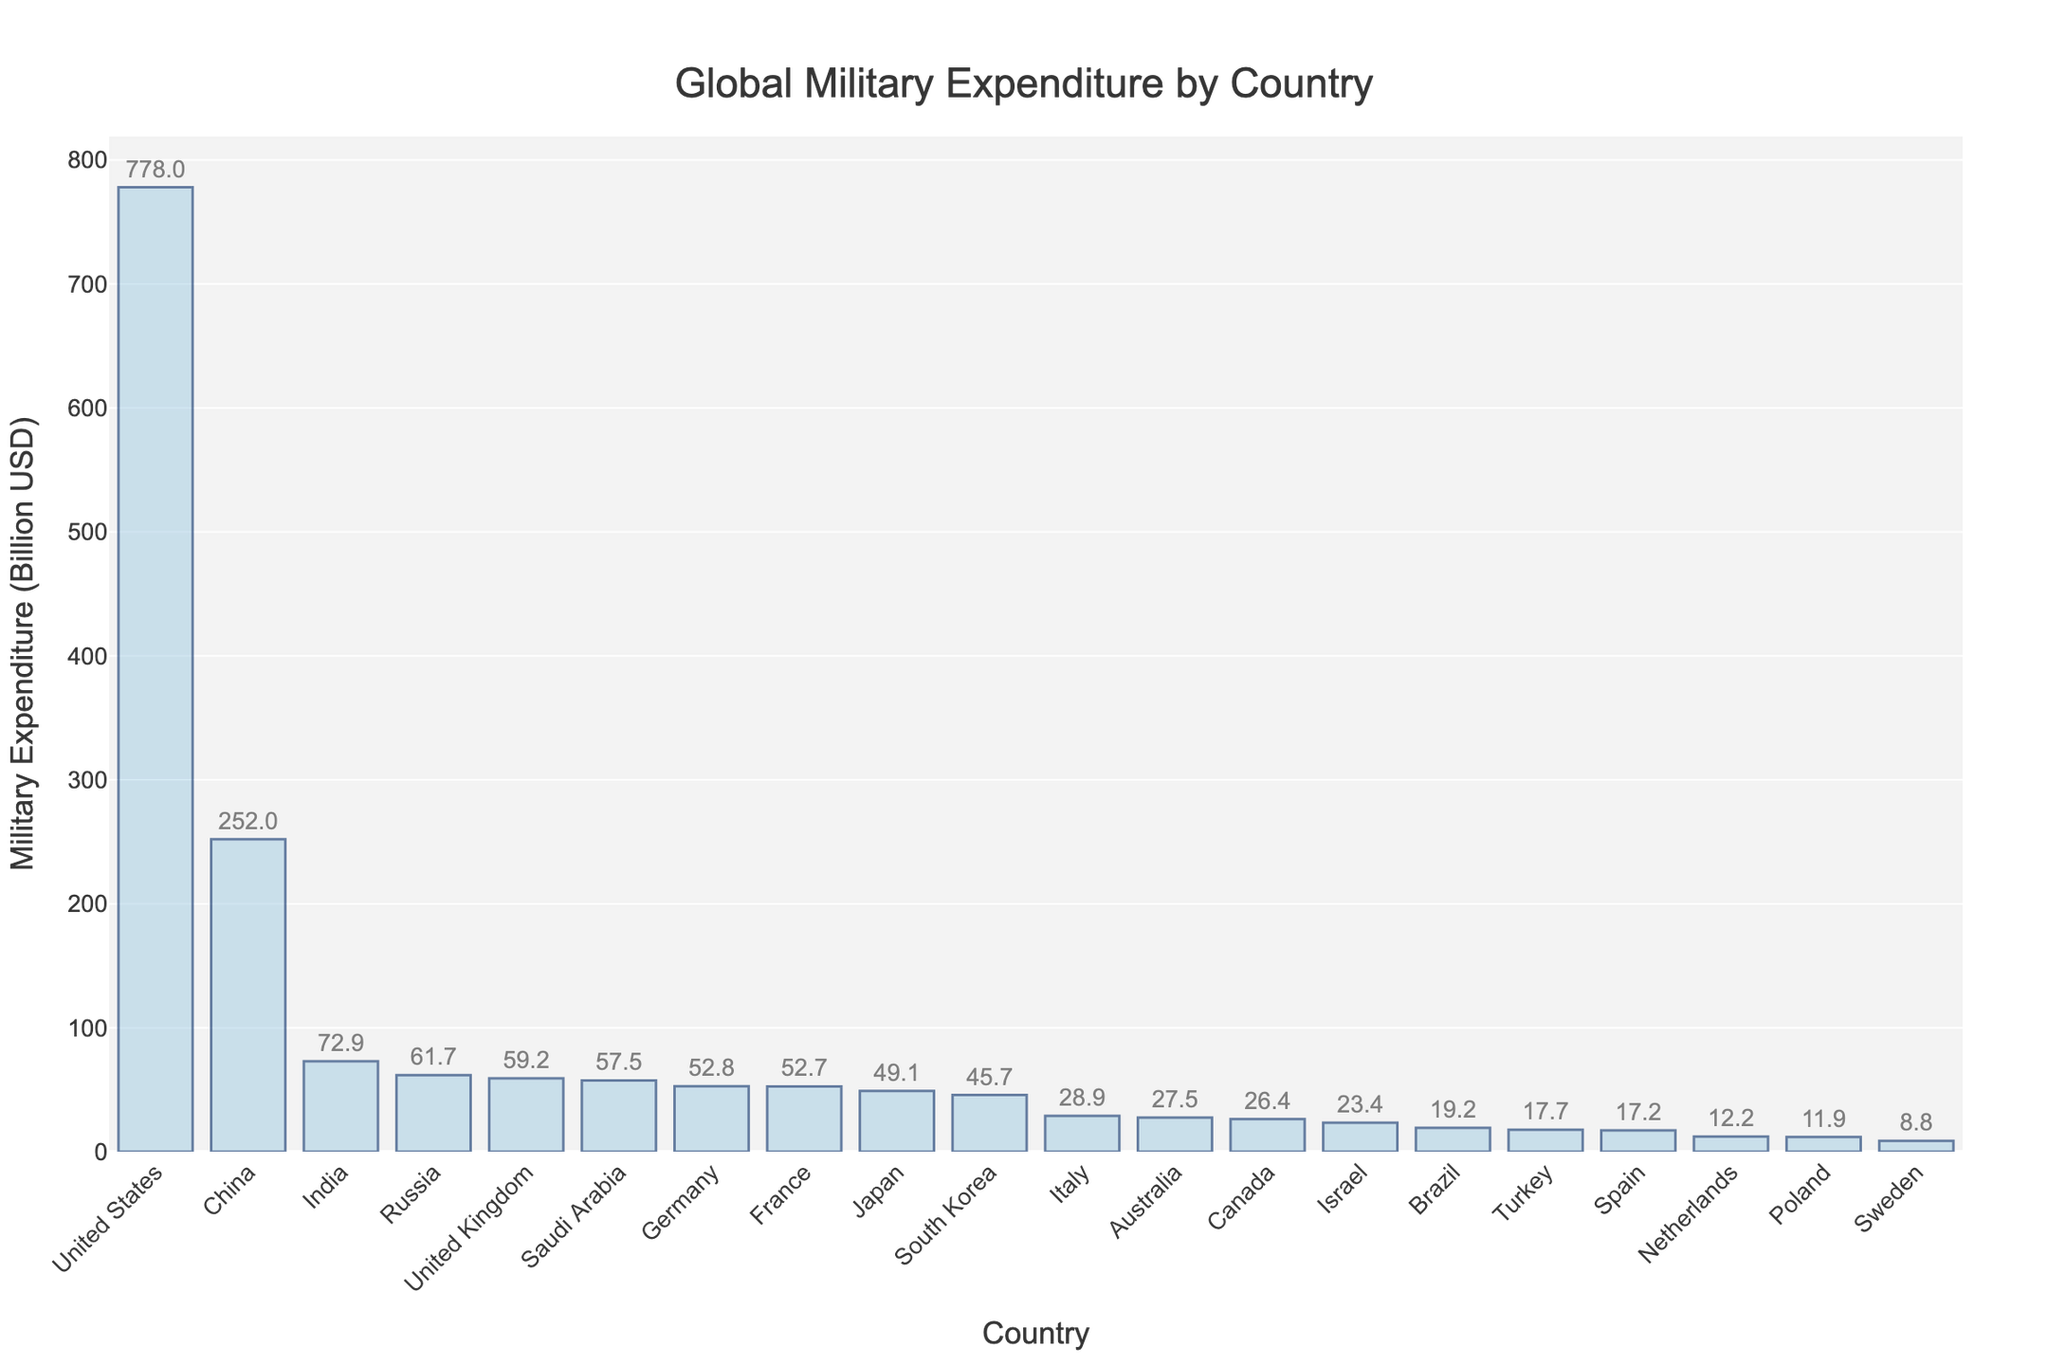Which country has the highest military expenditure? From the figure, the bar representing the United States is the tallest, indicating it has the highest military expenditure.
Answer: United States What is the total military expenditure of the top three countries? From the figure, the military expenditures of the top three countries are the United States (778 billion USD), China (252 billion USD), and India (72.9 billion USD). Adding these values together, 778 + 252 + 72.9 = 1102.9 billion USD.
Answer: 1102.9 billion USD How does the military expenditure of Russia compare to that of the United Kingdom? From the figure, the height of the bar for Russia (61.7 billion USD) is slightly higher than that for the United Kingdom (59.2 billion USD), meaning Russia spends more.
Answer: Russia spends more What is the difference in military expenditure between China and Japan? From the figure, the military expenditure of China is 252 billion USD and Japan is 49.1 billion USD. The difference is 252 - 49.1 = 202.9 billion USD.
Answer: 202.9 billion USD Which countries have a military expenditure of less than 30 billion USD? From the figure, the countries with bars indicating expenditures under 30 billion USD are Italy, Australia, Canada, Israel, Brazil, Turkey, Spain, Netherlands, Poland, and Sweden.
Answer: Italy, Australia, Canada, Israel, Brazil, Turkey, Spain, Netherlands, Poland, Sweden What is the average military expenditure of the five countries with the highest spending? From the figure, the top five countries are the United States (778 billion USD), China (252 billion USD), India (72.9 billion USD), Russia (61.7 billion USD), and the United Kingdom (59.2 billion USD). The average is (778 + 252 + 72.9 + 61.7 + 59.2) / 5 = 244.76 billion USD.
Answer: 244.76 billion USD By how much does Germany's military expenditure exceed that of Brazil? From the figure, Germany's expenditure is 52.8 billion USD, and Brazil's is 19.2 billion USD. The difference is 52.8 - 19.2 = 33.6 billion USD.
Answer: 33.6 billion USD Which country has the lowest military expenditure among the listed nations, and what is that amount? From the figure, the shortest bar belongs to Sweden, indicating the lowest expenditure, which is 8.8 billion USD.
Answer: Sweden, 8.8 billion USD What is the combined military expenditure of France and South Korea? From the figure, the military expenditures for France and South Korea are 52.7 billion USD and 45.7 billion USD, respectively. The combined expenditure is 52.7 + 45.7 = 98.4 billion USD.
Answer: 98.4 billion USD How many countries have military expenditures greater than 50 billion USD? From the figure, the countries with expenditures exceeding 50 billion USD are the United States, China, India, Russia, United Kingdom, Saudi Arabia, Germany, and France. There are 8 such countries.
Answer: 8 